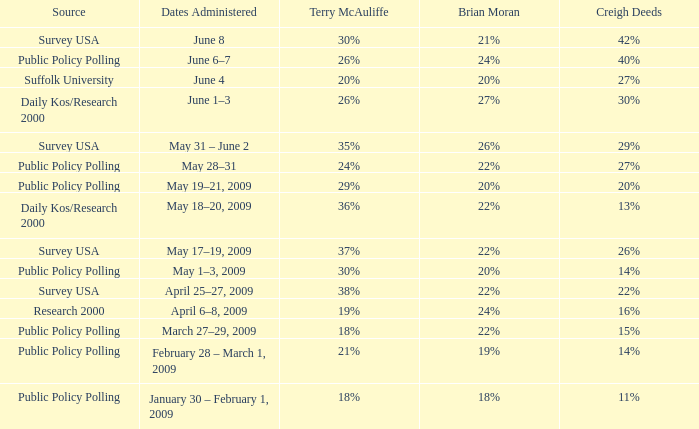Which origin has terry mcauliffe with 36%? Daily Kos/Research 2000. 